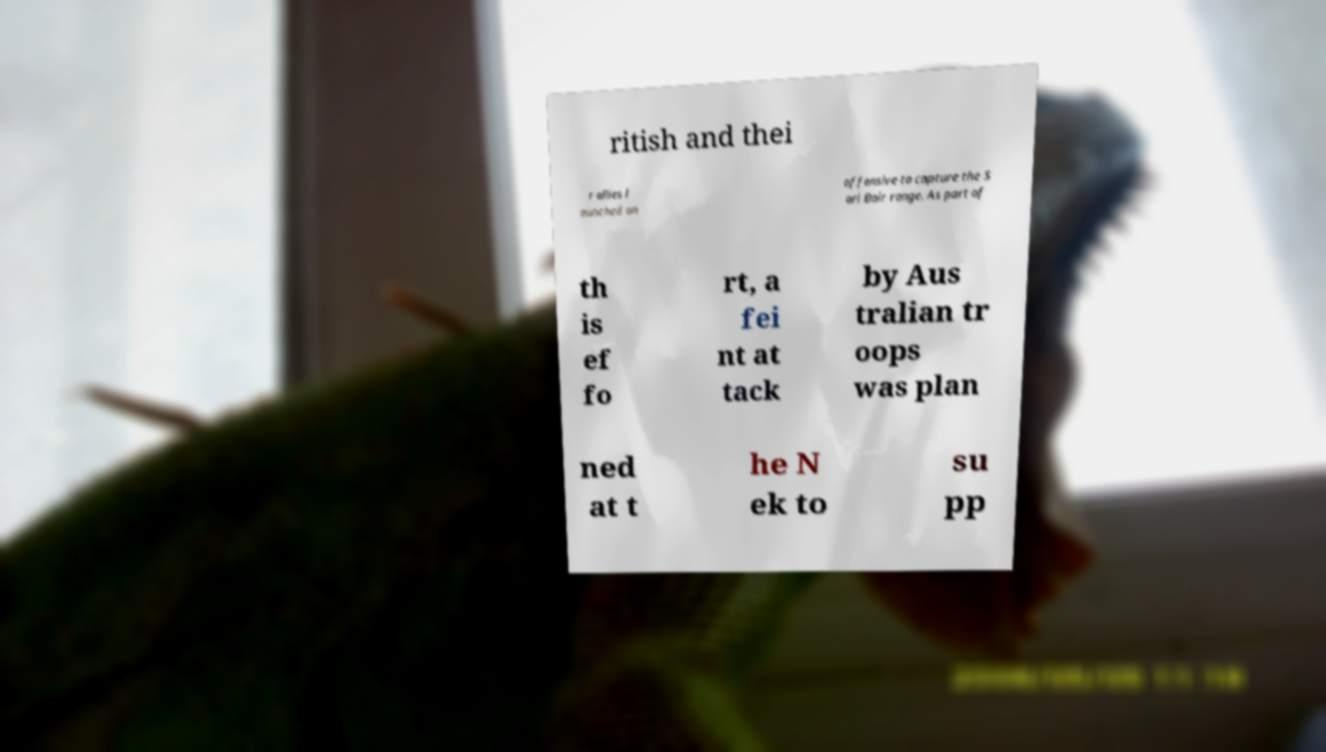Please identify and transcribe the text found in this image. ritish and thei r allies l aunched an offensive to capture the S ari Bair range. As part of th is ef fo rt, a fei nt at tack by Aus tralian tr oops was plan ned at t he N ek to su pp 